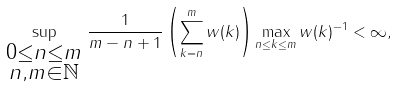Convert formula to latex. <formula><loc_0><loc_0><loc_500><loc_500>\sup _ { \begin{smallmatrix} 0 \leq n \leq m \\ n , m \in \mathbb { N } \end{smallmatrix} } \frac { 1 } { m - n + 1 } \left ( \sum _ { k = n } ^ { m } w ( k ) \right ) \max _ { n \leq k \leq m } w ( k ) ^ { - 1 } < \infty ,</formula> 